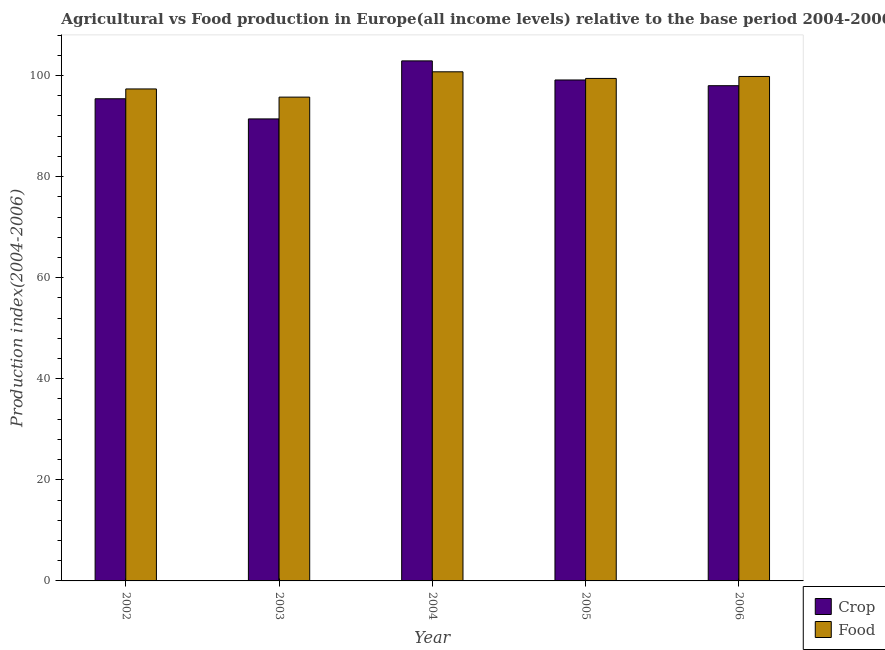How many groups of bars are there?
Give a very brief answer. 5. In how many cases, is the number of bars for a given year not equal to the number of legend labels?
Offer a very short reply. 0. What is the food production index in 2002?
Provide a short and direct response. 97.35. Across all years, what is the maximum food production index?
Your answer should be very brief. 100.75. Across all years, what is the minimum food production index?
Offer a very short reply. 95.74. In which year was the food production index minimum?
Offer a very short reply. 2003. What is the total food production index in the graph?
Ensure brevity in your answer.  493.09. What is the difference between the food production index in 2002 and that in 2003?
Make the answer very short. 1.62. What is the difference between the food production index in 2006 and the crop production index in 2003?
Make the answer very short. 4.09. What is the average crop production index per year?
Provide a succinct answer. 97.37. What is the ratio of the food production index in 2002 to that in 2004?
Your answer should be very brief. 0.97. Is the difference between the crop production index in 2002 and 2003 greater than the difference between the food production index in 2002 and 2003?
Ensure brevity in your answer.  No. What is the difference between the highest and the second highest crop production index?
Provide a succinct answer. 3.78. What is the difference between the highest and the lowest food production index?
Provide a short and direct response. 5.01. Is the sum of the food production index in 2002 and 2006 greater than the maximum crop production index across all years?
Ensure brevity in your answer.  Yes. What does the 1st bar from the left in 2004 represents?
Your answer should be compact. Crop. What does the 1st bar from the right in 2002 represents?
Offer a terse response. Food. How many bars are there?
Your answer should be very brief. 10. Are all the bars in the graph horizontal?
Give a very brief answer. No. How many years are there in the graph?
Keep it short and to the point. 5. Are the values on the major ticks of Y-axis written in scientific E-notation?
Ensure brevity in your answer.  No. Does the graph contain any zero values?
Offer a very short reply. No. Where does the legend appear in the graph?
Offer a very short reply. Bottom right. What is the title of the graph?
Your answer should be very brief. Agricultural vs Food production in Europe(all income levels) relative to the base period 2004-2006. Does "Urban" appear as one of the legend labels in the graph?
Make the answer very short. No. What is the label or title of the Y-axis?
Ensure brevity in your answer.  Production index(2004-2006). What is the Production index(2004-2006) in Crop in 2002?
Provide a succinct answer. 95.41. What is the Production index(2004-2006) in Food in 2002?
Your answer should be very brief. 97.35. What is the Production index(2004-2006) in Crop in 2003?
Give a very brief answer. 91.42. What is the Production index(2004-2006) in Food in 2003?
Ensure brevity in your answer.  95.74. What is the Production index(2004-2006) in Crop in 2004?
Ensure brevity in your answer.  102.91. What is the Production index(2004-2006) of Food in 2004?
Offer a terse response. 100.75. What is the Production index(2004-2006) of Crop in 2005?
Ensure brevity in your answer.  99.13. What is the Production index(2004-2006) in Food in 2005?
Give a very brief answer. 99.43. What is the Production index(2004-2006) in Crop in 2006?
Offer a very short reply. 98. What is the Production index(2004-2006) in Food in 2006?
Keep it short and to the point. 99.82. Across all years, what is the maximum Production index(2004-2006) of Crop?
Offer a terse response. 102.91. Across all years, what is the maximum Production index(2004-2006) of Food?
Your response must be concise. 100.75. Across all years, what is the minimum Production index(2004-2006) of Crop?
Provide a short and direct response. 91.42. Across all years, what is the minimum Production index(2004-2006) in Food?
Keep it short and to the point. 95.74. What is the total Production index(2004-2006) of Crop in the graph?
Keep it short and to the point. 486.86. What is the total Production index(2004-2006) in Food in the graph?
Keep it short and to the point. 493.09. What is the difference between the Production index(2004-2006) in Crop in 2002 and that in 2003?
Give a very brief answer. 3.99. What is the difference between the Production index(2004-2006) of Food in 2002 and that in 2003?
Provide a succinct answer. 1.62. What is the difference between the Production index(2004-2006) in Crop in 2002 and that in 2004?
Keep it short and to the point. -7.5. What is the difference between the Production index(2004-2006) of Food in 2002 and that in 2004?
Give a very brief answer. -3.39. What is the difference between the Production index(2004-2006) of Crop in 2002 and that in 2005?
Your answer should be very brief. -3.72. What is the difference between the Production index(2004-2006) of Food in 2002 and that in 2005?
Ensure brevity in your answer.  -2.08. What is the difference between the Production index(2004-2006) in Crop in 2002 and that in 2006?
Offer a terse response. -2.59. What is the difference between the Production index(2004-2006) in Food in 2002 and that in 2006?
Keep it short and to the point. -2.47. What is the difference between the Production index(2004-2006) of Crop in 2003 and that in 2004?
Ensure brevity in your answer.  -11.48. What is the difference between the Production index(2004-2006) in Food in 2003 and that in 2004?
Give a very brief answer. -5.01. What is the difference between the Production index(2004-2006) in Crop in 2003 and that in 2005?
Provide a short and direct response. -7.7. What is the difference between the Production index(2004-2006) of Food in 2003 and that in 2005?
Ensure brevity in your answer.  -3.7. What is the difference between the Production index(2004-2006) of Crop in 2003 and that in 2006?
Keep it short and to the point. -6.57. What is the difference between the Production index(2004-2006) in Food in 2003 and that in 2006?
Keep it short and to the point. -4.09. What is the difference between the Production index(2004-2006) in Crop in 2004 and that in 2005?
Make the answer very short. 3.78. What is the difference between the Production index(2004-2006) of Food in 2004 and that in 2005?
Provide a succinct answer. 1.31. What is the difference between the Production index(2004-2006) of Crop in 2004 and that in 2006?
Offer a very short reply. 4.91. What is the difference between the Production index(2004-2006) in Food in 2004 and that in 2006?
Provide a succinct answer. 0.92. What is the difference between the Production index(2004-2006) in Crop in 2005 and that in 2006?
Keep it short and to the point. 1.13. What is the difference between the Production index(2004-2006) of Food in 2005 and that in 2006?
Your response must be concise. -0.39. What is the difference between the Production index(2004-2006) of Crop in 2002 and the Production index(2004-2006) of Food in 2003?
Offer a terse response. -0.32. What is the difference between the Production index(2004-2006) of Crop in 2002 and the Production index(2004-2006) of Food in 2004?
Your answer should be very brief. -5.33. What is the difference between the Production index(2004-2006) of Crop in 2002 and the Production index(2004-2006) of Food in 2005?
Provide a succinct answer. -4.02. What is the difference between the Production index(2004-2006) of Crop in 2002 and the Production index(2004-2006) of Food in 2006?
Your response must be concise. -4.41. What is the difference between the Production index(2004-2006) in Crop in 2003 and the Production index(2004-2006) in Food in 2004?
Keep it short and to the point. -9.32. What is the difference between the Production index(2004-2006) of Crop in 2003 and the Production index(2004-2006) of Food in 2005?
Your response must be concise. -8.01. What is the difference between the Production index(2004-2006) of Crop in 2003 and the Production index(2004-2006) of Food in 2006?
Provide a succinct answer. -8.4. What is the difference between the Production index(2004-2006) of Crop in 2004 and the Production index(2004-2006) of Food in 2005?
Offer a very short reply. 3.47. What is the difference between the Production index(2004-2006) of Crop in 2004 and the Production index(2004-2006) of Food in 2006?
Keep it short and to the point. 3.08. What is the difference between the Production index(2004-2006) in Crop in 2005 and the Production index(2004-2006) in Food in 2006?
Your answer should be compact. -0.7. What is the average Production index(2004-2006) in Crop per year?
Offer a very short reply. 97.37. What is the average Production index(2004-2006) of Food per year?
Your answer should be very brief. 98.62. In the year 2002, what is the difference between the Production index(2004-2006) of Crop and Production index(2004-2006) of Food?
Ensure brevity in your answer.  -1.94. In the year 2003, what is the difference between the Production index(2004-2006) in Crop and Production index(2004-2006) in Food?
Keep it short and to the point. -4.31. In the year 2004, what is the difference between the Production index(2004-2006) of Crop and Production index(2004-2006) of Food?
Keep it short and to the point. 2.16. In the year 2005, what is the difference between the Production index(2004-2006) of Crop and Production index(2004-2006) of Food?
Ensure brevity in your answer.  -0.31. In the year 2006, what is the difference between the Production index(2004-2006) in Crop and Production index(2004-2006) in Food?
Give a very brief answer. -1.83. What is the ratio of the Production index(2004-2006) in Crop in 2002 to that in 2003?
Offer a terse response. 1.04. What is the ratio of the Production index(2004-2006) of Food in 2002 to that in 2003?
Ensure brevity in your answer.  1.02. What is the ratio of the Production index(2004-2006) of Crop in 2002 to that in 2004?
Your answer should be very brief. 0.93. What is the ratio of the Production index(2004-2006) of Food in 2002 to that in 2004?
Give a very brief answer. 0.97. What is the ratio of the Production index(2004-2006) of Crop in 2002 to that in 2005?
Provide a succinct answer. 0.96. What is the ratio of the Production index(2004-2006) of Food in 2002 to that in 2005?
Ensure brevity in your answer.  0.98. What is the ratio of the Production index(2004-2006) in Crop in 2002 to that in 2006?
Keep it short and to the point. 0.97. What is the ratio of the Production index(2004-2006) in Food in 2002 to that in 2006?
Ensure brevity in your answer.  0.98. What is the ratio of the Production index(2004-2006) in Crop in 2003 to that in 2004?
Your answer should be very brief. 0.89. What is the ratio of the Production index(2004-2006) in Food in 2003 to that in 2004?
Your answer should be compact. 0.95. What is the ratio of the Production index(2004-2006) of Crop in 2003 to that in 2005?
Ensure brevity in your answer.  0.92. What is the ratio of the Production index(2004-2006) of Food in 2003 to that in 2005?
Ensure brevity in your answer.  0.96. What is the ratio of the Production index(2004-2006) in Crop in 2003 to that in 2006?
Your answer should be compact. 0.93. What is the ratio of the Production index(2004-2006) in Food in 2003 to that in 2006?
Provide a succinct answer. 0.96. What is the ratio of the Production index(2004-2006) in Crop in 2004 to that in 2005?
Keep it short and to the point. 1.04. What is the ratio of the Production index(2004-2006) of Food in 2004 to that in 2005?
Provide a succinct answer. 1.01. What is the ratio of the Production index(2004-2006) in Crop in 2004 to that in 2006?
Keep it short and to the point. 1.05. What is the ratio of the Production index(2004-2006) in Food in 2004 to that in 2006?
Your response must be concise. 1.01. What is the ratio of the Production index(2004-2006) in Crop in 2005 to that in 2006?
Give a very brief answer. 1.01. What is the ratio of the Production index(2004-2006) of Food in 2005 to that in 2006?
Your response must be concise. 1. What is the difference between the highest and the second highest Production index(2004-2006) in Crop?
Give a very brief answer. 3.78. What is the difference between the highest and the second highest Production index(2004-2006) of Food?
Your response must be concise. 0.92. What is the difference between the highest and the lowest Production index(2004-2006) of Crop?
Provide a succinct answer. 11.48. What is the difference between the highest and the lowest Production index(2004-2006) of Food?
Provide a short and direct response. 5.01. 